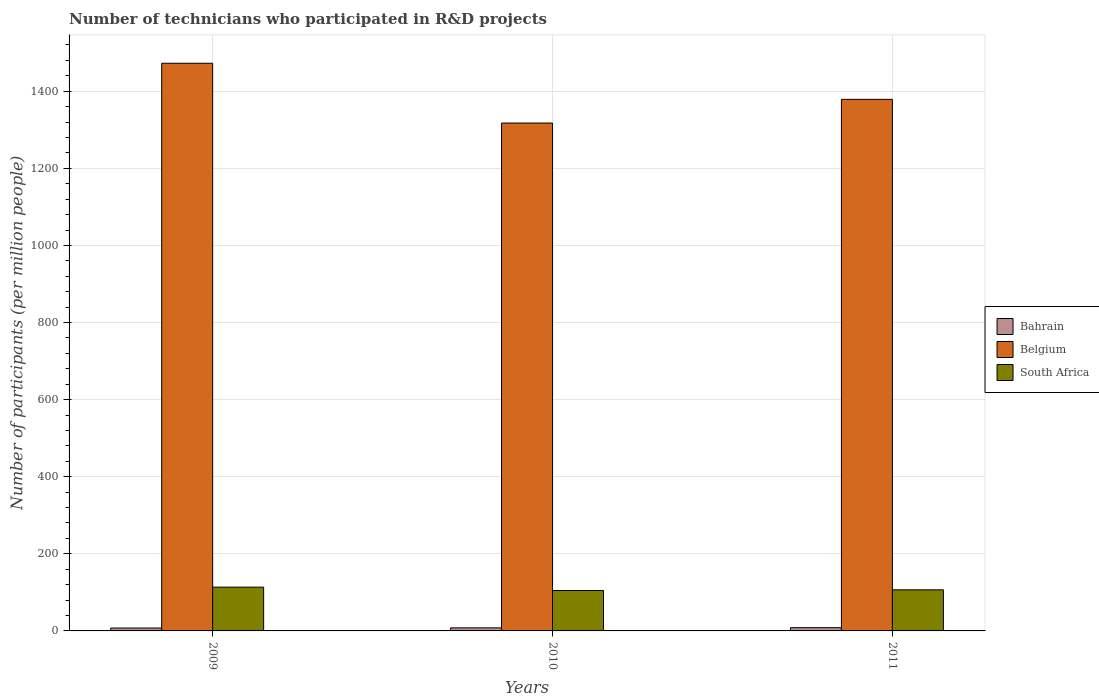Are the number of bars on each tick of the X-axis equal?
Make the answer very short. Yes. How many bars are there on the 1st tick from the left?
Provide a short and direct response. 3. What is the number of technicians who participated in R&D projects in Bahrain in 2010?
Provide a short and direct response. 7.93. Across all years, what is the maximum number of technicians who participated in R&D projects in Belgium?
Your answer should be compact. 1472.61. Across all years, what is the minimum number of technicians who participated in R&D projects in Bahrain?
Offer a terse response. 7.52. In which year was the number of technicians who participated in R&D projects in Belgium maximum?
Provide a short and direct response. 2009. In which year was the number of technicians who participated in R&D projects in Bahrain minimum?
Provide a short and direct response. 2009. What is the total number of technicians who participated in R&D projects in South Africa in the graph?
Give a very brief answer. 324.95. What is the difference between the number of technicians who participated in R&D projects in Bahrain in 2009 and that in 2010?
Keep it short and to the point. -0.41. What is the difference between the number of technicians who participated in R&D projects in Bahrain in 2011 and the number of technicians who participated in R&D projects in South Africa in 2009?
Give a very brief answer. -105.17. What is the average number of technicians who participated in R&D projects in Bahrain per year?
Your response must be concise. 7.96. In the year 2009, what is the difference between the number of technicians who participated in R&D projects in Belgium and number of technicians who participated in R&D projects in Bahrain?
Give a very brief answer. 1465.09. In how many years, is the number of technicians who participated in R&D projects in South Africa greater than 840?
Your answer should be very brief. 0. What is the ratio of the number of technicians who participated in R&D projects in Belgium in 2010 to that in 2011?
Your answer should be very brief. 0.96. What is the difference between the highest and the second highest number of technicians who participated in R&D projects in Belgium?
Ensure brevity in your answer.  93.63. What is the difference between the highest and the lowest number of technicians who participated in R&D projects in Belgium?
Give a very brief answer. 155.08. What does the 3rd bar from the left in 2010 represents?
Keep it short and to the point. South Africa. How many bars are there?
Provide a short and direct response. 9. Are all the bars in the graph horizontal?
Make the answer very short. No. Does the graph contain any zero values?
Offer a very short reply. No. Does the graph contain grids?
Your answer should be compact. Yes. What is the title of the graph?
Offer a very short reply. Number of technicians who participated in R&D projects. What is the label or title of the X-axis?
Ensure brevity in your answer.  Years. What is the label or title of the Y-axis?
Offer a very short reply. Number of participants (per million people). What is the Number of participants (per million people) of Bahrain in 2009?
Your response must be concise. 7.52. What is the Number of participants (per million people) in Belgium in 2009?
Your answer should be compact. 1472.61. What is the Number of participants (per million people) of South Africa in 2009?
Your answer should be very brief. 113.59. What is the Number of participants (per million people) in Bahrain in 2010?
Provide a short and direct response. 7.93. What is the Number of participants (per million people) of Belgium in 2010?
Offer a very short reply. 1317.54. What is the Number of participants (per million people) of South Africa in 2010?
Your response must be concise. 104.79. What is the Number of participants (per million people) in Bahrain in 2011?
Provide a succinct answer. 8.42. What is the Number of participants (per million people) in Belgium in 2011?
Your answer should be very brief. 1378.98. What is the Number of participants (per million people) in South Africa in 2011?
Provide a short and direct response. 106.57. Across all years, what is the maximum Number of participants (per million people) in Bahrain?
Provide a succinct answer. 8.42. Across all years, what is the maximum Number of participants (per million people) of Belgium?
Your answer should be very brief. 1472.61. Across all years, what is the maximum Number of participants (per million people) in South Africa?
Ensure brevity in your answer.  113.59. Across all years, what is the minimum Number of participants (per million people) in Bahrain?
Offer a terse response. 7.52. Across all years, what is the minimum Number of participants (per million people) of Belgium?
Ensure brevity in your answer.  1317.54. Across all years, what is the minimum Number of participants (per million people) of South Africa?
Your answer should be compact. 104.79. What is the total Number of participants (per million people) of Bahrain in the graph?
Ensure brevity in your answer.  23.87. What is the total Number of participants (per million people) in Belgium in the graph?
Give a very brief answer. 4169.13. What is the total Number of participants (per million people) of South Africa in the graph?
Offer a terse response. 324.95. What is the difference between the Number of participants (per million people) of Bahrain in 2009 and that in 2010?
Keep it short and to the point. -0.41. What is the difference between the Number of participants (per million people) of Belgium in 2009 and that in 2010?
Provide a succinct answer. 155.08. What is the difference between the Number of participants (per million people) in South Africa in 2009 and that in 2010?
Provide a short and direct response. 8.8. What is the difference between the Number of participants (per million people) in Bahrain in 2009 and that in 2011?
Your answer should be compact. -0.9. What is the difference between the Number of participants (per million people) of Belgium in 2009 and that in 2011?
Provide a succinct answer. 93.63. What is the difference between the Number of participants (per million people) of South Africa in 2009 and that in 2011?
Provide a short and direct response. 7.02. What is the difference between the Number of participants (per million people) of Bahrain in 2010 and that in 2011?
Provide a succinct answer. -0.49. What is the difference between the Number of participants (per million people) in Belgium in 2010 and that in 2011?
Give a very brief answer. -61.45. What is the difference between the Number of participants (per million people) in South Africa in 2010 and that in 2011?
Your answer should be compact. -1.78. What is the difference between the Number of participants (per million people) of Bahrain in 2009 and the Number of participants (per million people) of Belgium in 2010?
Your answer should be very brief. -1310.02. What is the difference between the Number of participants (per million people) in Bahrain in 2009 and the Number of participants (per million people) in South Africa in 2010?
Make the answer very short. -97.27. What is the difference between the Number of participants (per million people) in Belgium in 2009 and the Number of participants (per million people) in South Africa in 2010?
Offer a terse response. 1367.82. What is the difference between the Number of participants (per million people) of Bahrain in 2009 and the Number of participants (per million people) of Belgium in 2011?
Provide a short and direct response. -1371.46. What is the difference between the Number of participants (per million people) in Bahrain in 2009 and the Number of participants (per million people) in South Africa in 2011?
Provide a short and direct response. -99.05. What is the difference between the Number of participants (per million people) of Belgium in 2009 and the Number of participants (per million people) of South Africa in 2011?
Give a very brief answer. 1366.04. What is the difference between the Number of participants (per million people) of Bahrain in 2010 and the Number of participants (per million people) of Belgium in 2011?
Give a very brief answer. -1371.05. What is the difference between the Number of participants (per million people) of Bahrain in 2010 and the Number of participants (per million people) of South Africa in 2011?
Give a very brief answer. -98.64. What is the difference between the Number of participants (per million people) of Belgium in 2010 and the Number of participants (per million people) of South Africa in 2011?
Your answer should be very brief. 1210.97. What is the average Number of participants (per million people) of Bahrain per year?
Ensure brevity in your answer.  7.96. What is the average Number of participants (per million people) of Belgium per year?
Give a very brief answer. 1389.71. What is the average Number of participants (per million people) in South Africa per year?
Your response must be concise. 108.32. In the year 2009, what is the difference between the Number of participants (per million people) of Bahrain and Number of participants (per million people) of Belgium?
Your response must be concise. -1465.09. In the year 2009, what is the difference between the Number of participants (per million people) of Bahrain and Number of participants (per million people) of South Africa?
Give a very brief answer. -106.07. In the year 2009, what is the difference between the Number of participants (per million people) of Belgium and Number of participants (per million people) of South Africa?
Make the answer very short. 1359.02. In the year 2010, what is the difference between the Number of participants (per million people) in Bahrain and Number of participants (per million people) in Belgium?
Keep it short and to the point. -1309.61. In the year 2010, what is the difference between the Number of participants (per million people) in Bahrain and Number of participants (per million people) in South Africa?
Ensure brevity in your answer.  -96.87. In the year 2010, what is the difference between the Number of participants (per million people) of Belgium and Number of participants (per million people) of South Africa?
Your response must be concise. 1212.74. In the year 2011, what is the difference between the Number of participants (per million people) of Bahrain and Number of participants (per million people) of Belgium?
Give a very brief answer. -1370.56. In the year 2011, what is the difference between the Number of participants (per million people) of Bahrain and Number of participants (per million people) of South Africa?
Your response must be concise. -98.15. In the year 2011, what is the difference between the Number of participants (per million people) in Belgium and Number of participants (per million people) in South Africa?
Provide a succinct answer. 1272.41. What is the ratio of the Number of participants (per million people) in Bahrain in 2009 to that in 2010?
Your answer should be very brief. 0.95. What is the ratio of the Number of participants (per million people) in Belgium in 2009 to that in 2010?
Your answer should be very brief. 1.12. What is the ratio of the Number of participants (per million people) in South Africa in 2009 to that in 2010?
Your response must be concise. 1.08. What is the ratio of the Number of participants (per million people) in Bahrain in 2009 to that in 2011?
Your answer should be very brief. 0.89. What is the ratio of the Number of participants (per million people) of Belgium in 2009 to that in 2011?
Give a very brief answer. 1.07. What is the ratio of the Number of participants (per million people) in South Africa in 2009 to that in 2011?
Your answer should be very brief. 1.07. What is the ratio of the Number of participants (per million people) of Bahrain in 2010 to that in 2011?
Provide a succinct answer. 0.94. What is the ratio of the Number of participants (per million people) of Belgium in 2010 to that in 2011?
Your answer should be very brief. 0.96. What is the ratio of the Number of participants (per million people) in South Africa in 2010 to that in 2011?
Offer a very short reply. 0.98. What is the difference between the highest and the second highest Number of participants (per million people) in Bahrain?
Make the answer very short. 0.49. What is the difference between the highest and the second highest Number of participants (per million people) of Belgium?
Provide a short and direct response. 93.63. What is the difference between the highest and the second highest Number of participants (per million people) of South Africa?
Make the answer very short. 7.02. What is the difference between the highest and the lowest Number of participants (per million people) in Bahrain?
Provide a short and direct response. 0.9. What is the difference between the highest and the lowest Number of participants (per million people) in Belgium?
Provide a succinct answer. 155.08. What is the difference between the highest and the lowest Number of participants (per million people) of South Africa?
Ensure brevity in your answer.  8.8. 